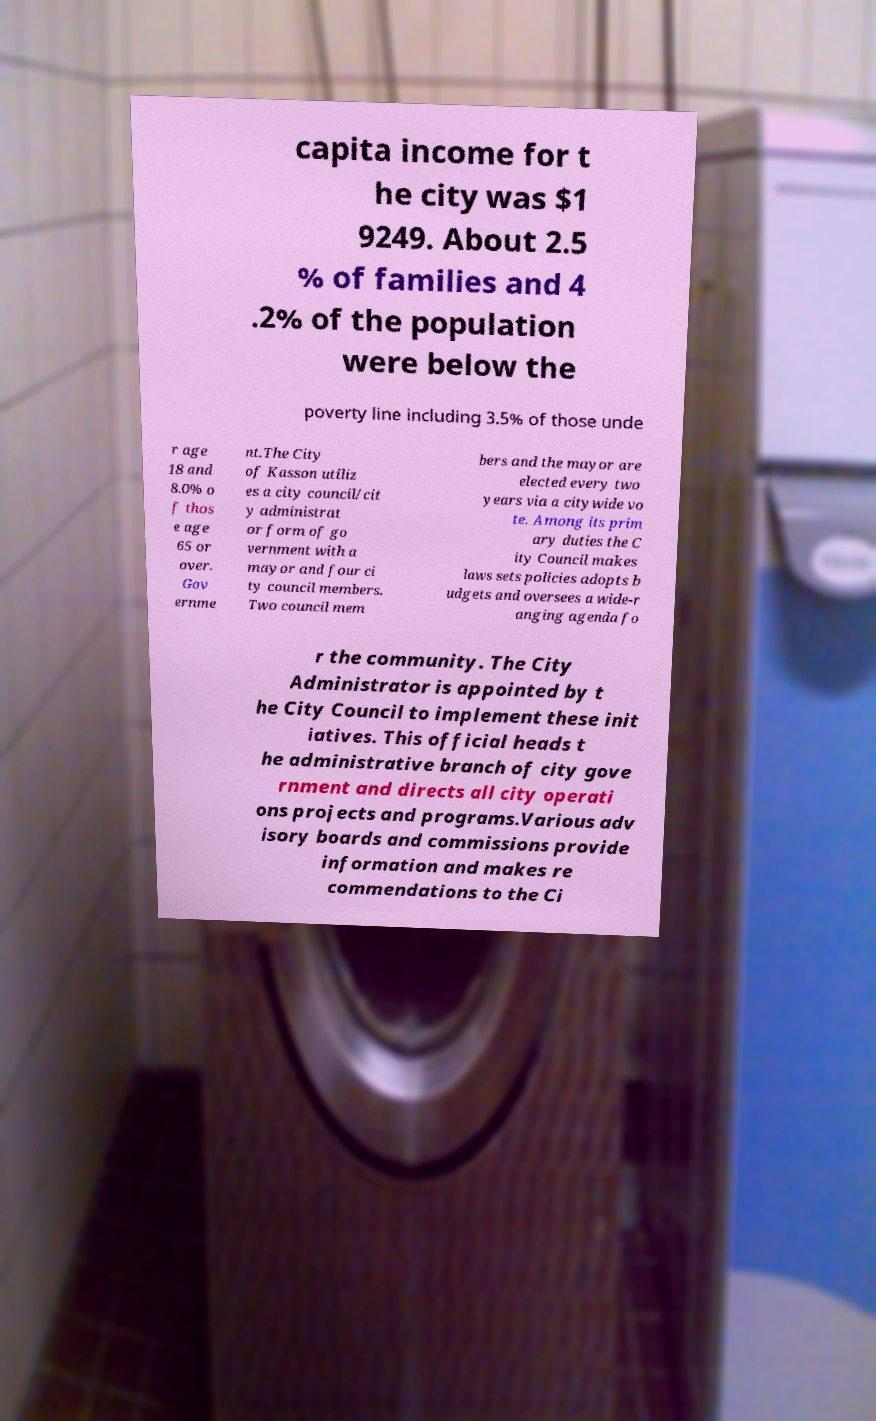Could you assist in decoding the text presented in this image and type it out clearly? capita income for t he city was $1 9249. About 2.5 % of families and 4 .2% of the population were below the poverty line including 3.5% of those unde r age 18 and 8.0% o f thos e age 65 or over. Gov ernme nt.The City of Kasson utiliz es a city council/cit y administrat or form of go vernment with a mayor and four ci ty council members. Two council mem bers and the mayor are elected every two years via a citywide vo te. Among its prim ary duties the C ity Council makes laws sets policies adopts b udgets and oversees a wide-r anging agenda fo r the community. The City Administrator is appointed by t he City Council to implement these init iatives. This official heads t he administrative branch of city gove rnment and directs all city operati ons projects and programs.Various adv isory boards and commissions provide information and makes re commendations to the Ci 